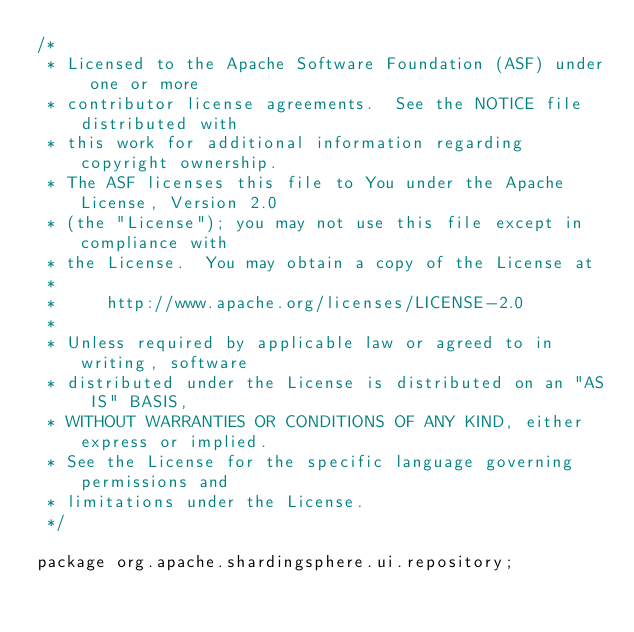Convert code to text. <code><loc_0><loc_0><loc_500><loc_500><_Java_>/*
 * Licensed to the Apache Software Foundation (ASF) under one or more
 * contributor license agreements.  See the NOTICE file distributed with
 * this work for additional information regarding copyright ownership.
 * The ASF licenses this file to You under the Apache License, Version 2.0
 * (the "License"); you may not use this file except in compliance with
 * the License.  You may obtain a copy of the License at
 *
 *     http://www.apache.org/licenses/LICENSE-2.0
 *
 * Unless required by applicable law or agreed to in writing, software
 * distributed under the License is distributed on an "AS IS" BASIS,
 * WITHOUT WARRANTIES OR CONDITIONS OF ANY KIND, either express or implied.
 * See the License for the specific language governing permissions and
 * limitations under the License.
 */

package org.apache.shardingsphere.ui.repository;
</code> 